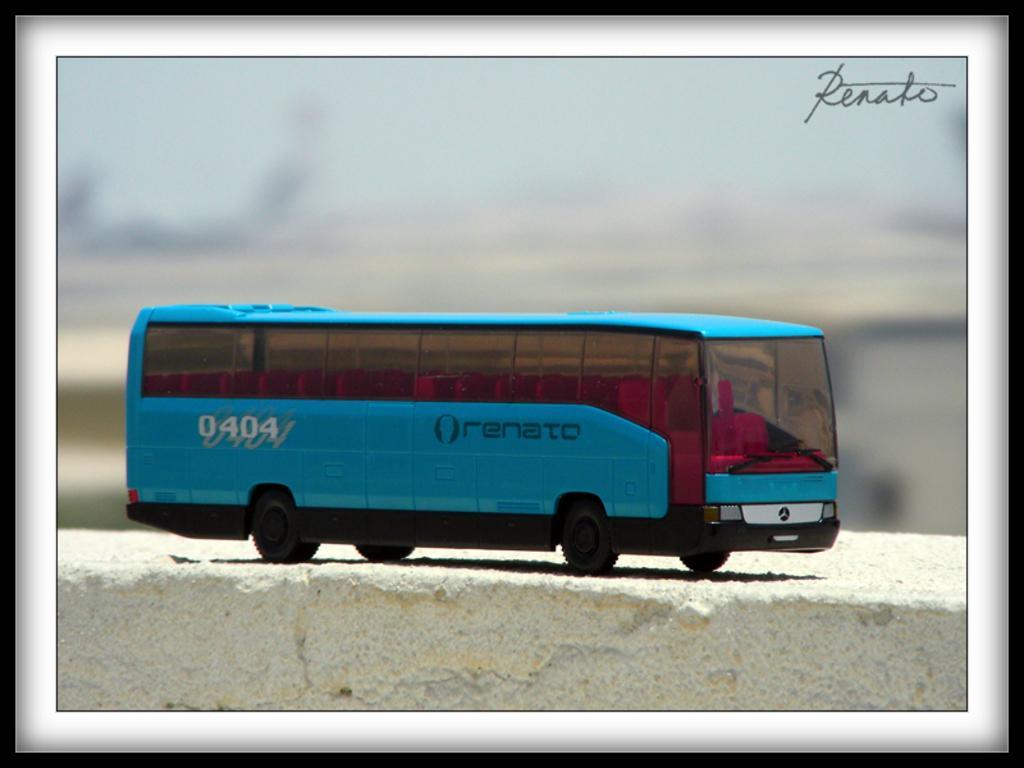How would you summarize this image in a sentence or two? In this image we can see that it looks like an edited image. In this image we can see a toy bus. At the bottom of the image there is a rocky surface. In the background of the image there is a blur background. On the image there is a watermark. 